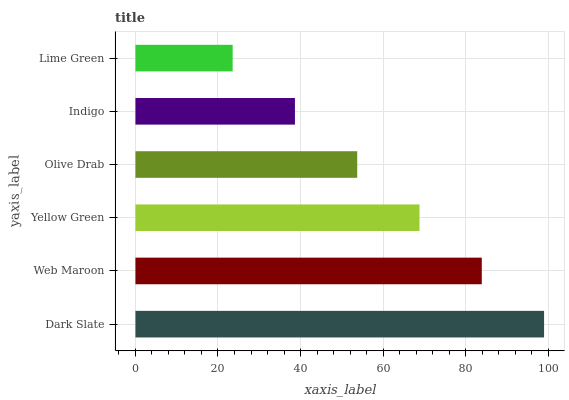Is Lime Green the minimum?
Answer yes or no. Yes. Is Dark Slate the maximum?
Answer yes or no. Yes. Is Web Maroon the minimum?
Answer yes or no. No. Is Web Maroon the maximum?
Answer yes or no. No. Is Dark Slate greater than Web Maroon?
Answer yes or no. Yes. Is Web Maroon less than Dark Slate?
Answer yes or no. Yes. Is Web Maroon greater than Dark Slate?
Answer yes or no. No. Is Dark Slate less than Web Maroon?
Answer yes or no. No. Is Yellow Green the high median?
Answer yes or no. Yes. Is Olive Drab the low median?
Answer yes or no. Yes. Is Indigo the high median?
Answer yes or no. No. Is Yellow Green the low median?
Answer yes or no. No. 